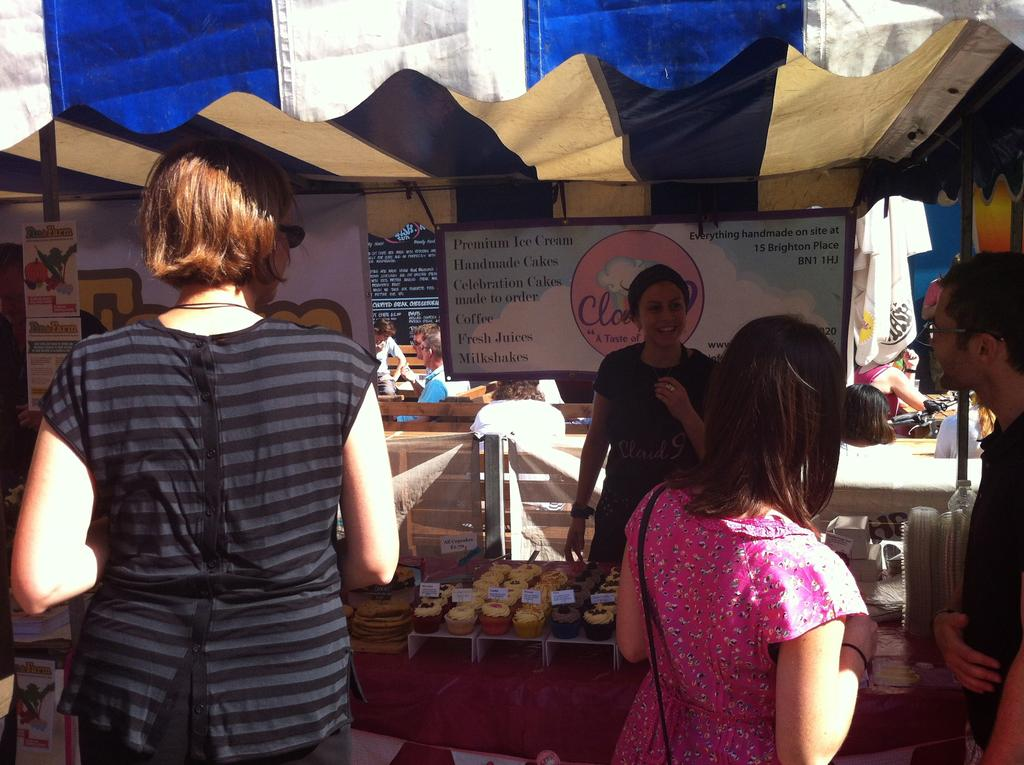What type of establishment is located in the middle of the image? There is a store in the middle of the image. What can be seen at the bottom of the image? There are food items at the bottom of the image. Where is the girl positioned in the image? The girl is standing on the left side of the image. What is the girl looking at? The girl is looking at the store. What structure is located at the top of the image? There is a tent at the top of the image. How many dogs are visible in the image? There are no dogs present in the image. What type of steam is coming from the food items at the bottom of the image? There is no steam present in the image; it only shows food items. What is the weight of the tent at the top of the image? The weight of the tent cannot be determined from the image, as it only shows the tent's appearance and not its physical properties. 